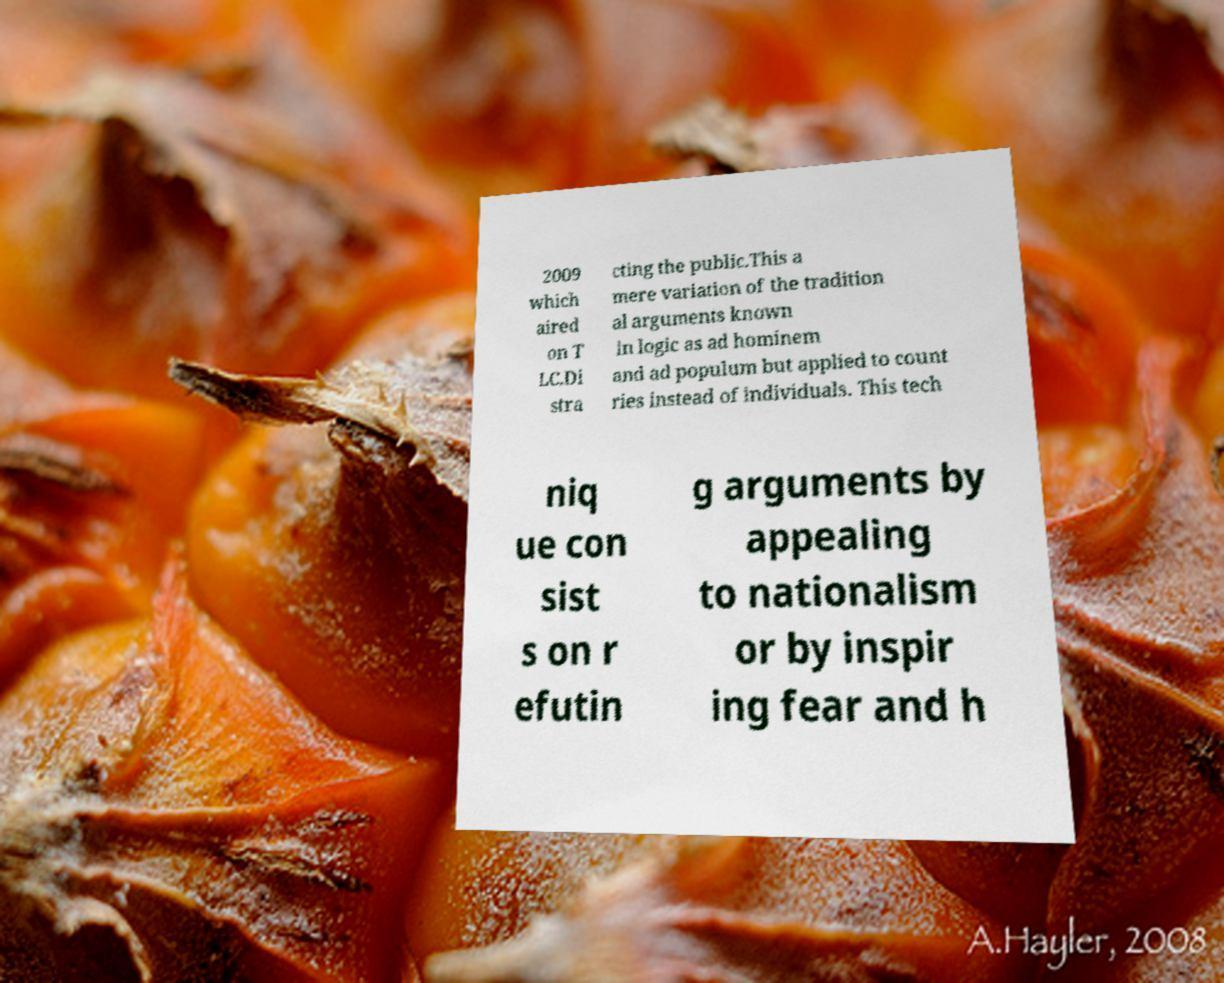For documentation purposes, I need the text within this image transcribed. Could you provide that? 2009 which aired on T LC.Di stra cting the public.This a mere variation of the tradition al arguments known in logic as ad hominem and ad populum but applied to count ries instead of individuals. This tech niq ue con sist s on r efutin g arguments by appealing to nationalism or by inspir ing fear and h 